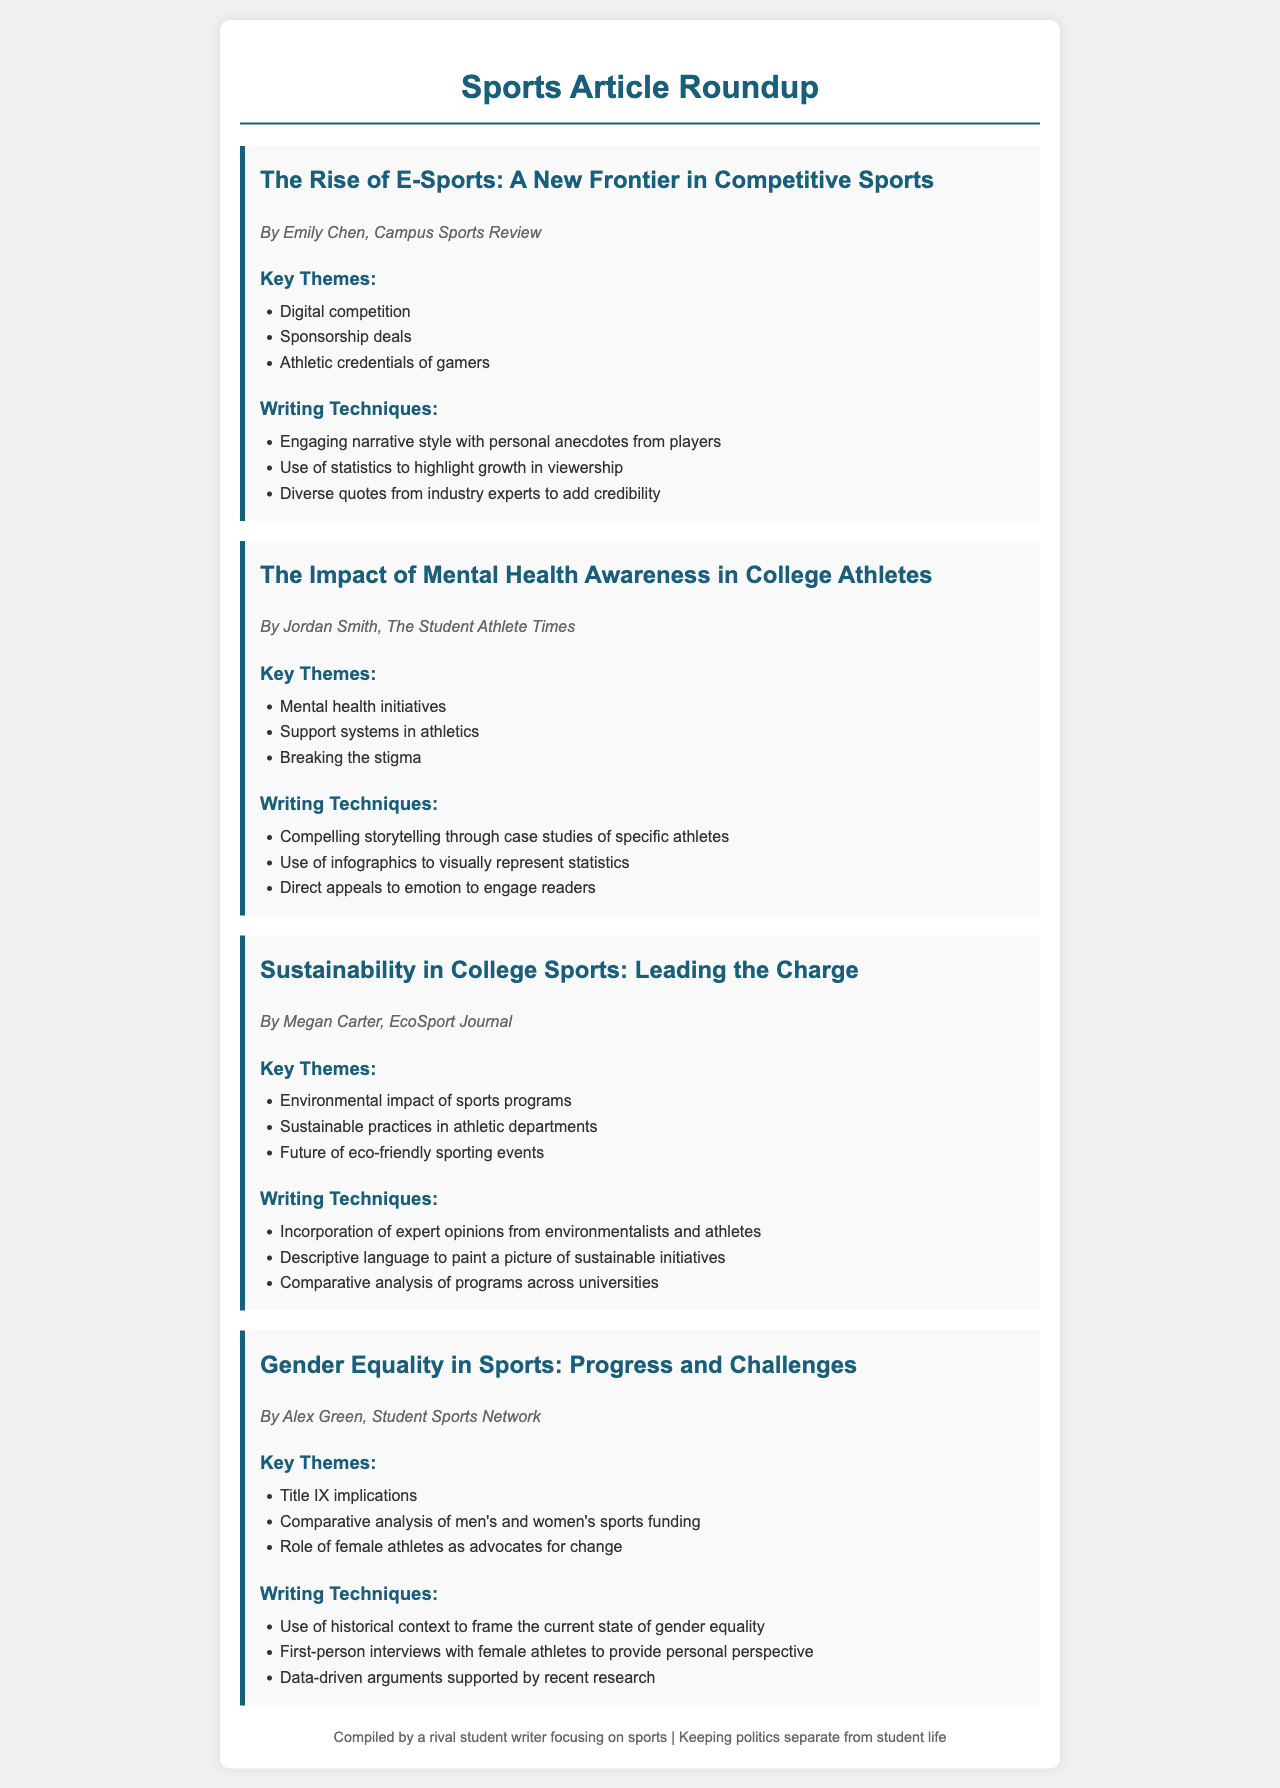What is the title of Emily Chen's article? Emily Chen's article is titled "The Rise of E-Sports: A New Frontier in Competitive Sports".
Answer: The Rise of E-Sports: A New Frontier in Competitive Sports What key theme does Jordan Smith's article focus on? One of the key themes in Jordan Smith's article is "Mental health initiatives".
Answer: Mental health initiatives How many articles are included in the roundup? There are four articles included in the roundup.
Answer: Four Which writing technique is highlighted in Megan Carter's article? A highlighted writing technique in Megan Carter's article is "Incorporation of expert opinions from environmentalists and athletes".
Answer: Incorporation of expert opinions from environmentalists and athletes What is the name of the publication that features Alex Green's article? Alex Green's article is featured in the "Student Sports Network".
Answer: Student Sports Network What statistical element is mentioned in Emily Chen's article? Emily Chen's article mentions "statistics to highlight growth in viewership".
Answer: Statistics to highlight growth in viewership What is a theme discussed in the article about gender equality in sports? A theme discussed in the article is "Title IX implications".
Answer: Title IX implications Which writing technique involves "first-person interviews" according to the document? This writing technique is found in Alex Green's article on gender equality in sports.
Answer: Alex Green's article What is the focus of the article written by Jordan Smith? Jordan Smith's article focuses on "The Impact of Mental Health Awareness in College Athletes".
Answer: The Impact of Mental Health Awareness in College Athletes 